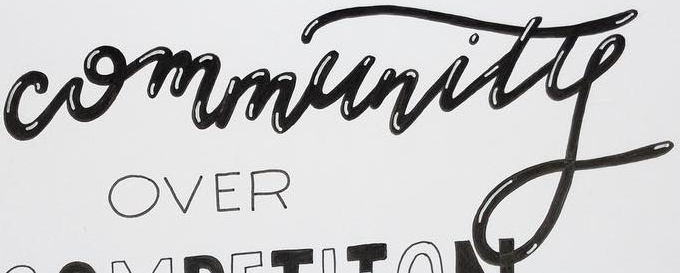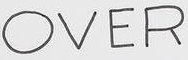Read the text from these images in sequence, separated by a semicolon. Community; OVER 